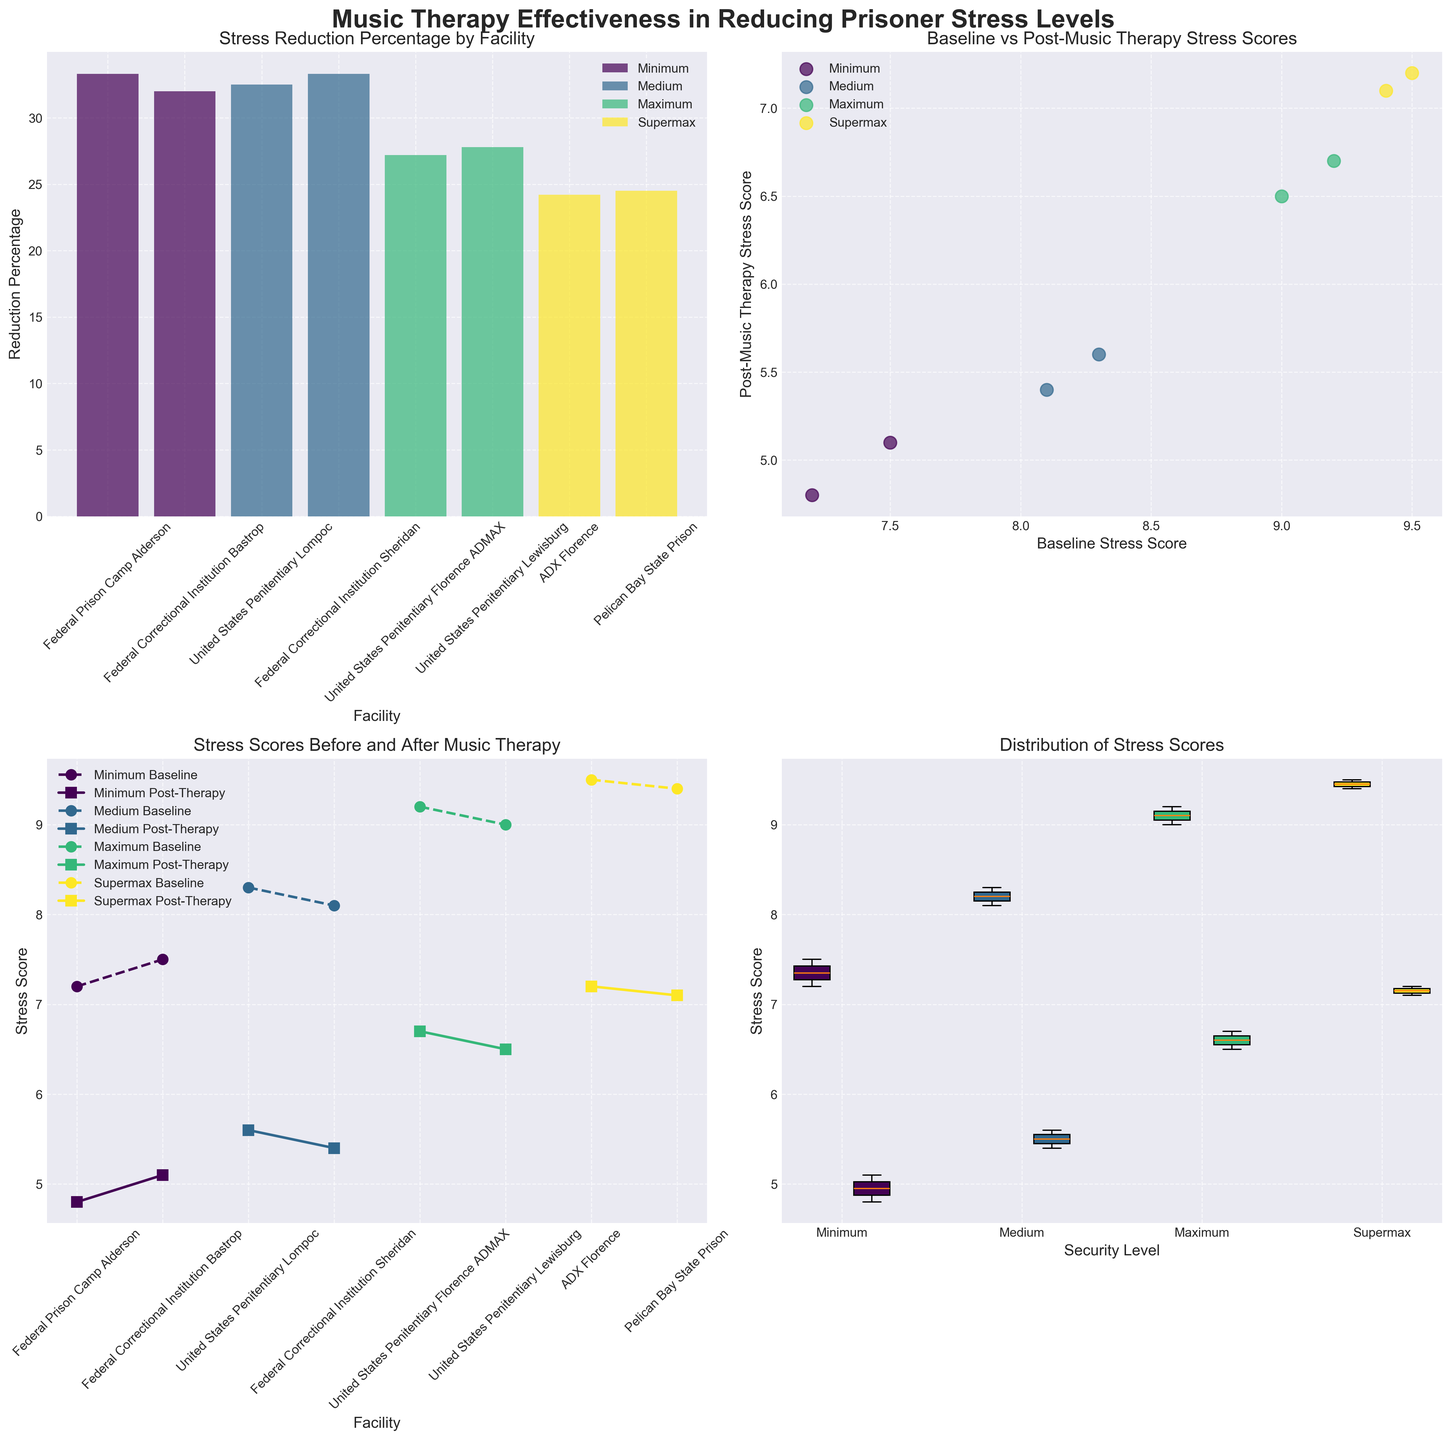Which facility within the Minimum Security Level shows the greatest reduction percentage? Look at the bar plot and identify the higher bar among the Minimum Security Level facilities. Federal Prison Camp Alderson shows a reduction percentage of 33.3, which is higher than 32.0 of the other facility.
Answer: Federal Prison Camp Alderson What's the difference between the Baseline and Post-Music Therapy Stress Scores for United States Penitentiary Florence ADMAX? Refer to the line plot and identify the values for Baseline and Post-Music Therapy Stress Scores for United States Penitentiary Florence ADMAX. The difference is calculated as 9.2 - 6.7.
Answer: 2.5 Which Security Level has the highest average Post-Music Therapy Stress Score? Look at the scatter plot for Post-Music Therapy Stress Scores for each Security Level. Calculate the average for each and compare. The Supermax level has the highest average with scores 7.2 and 7.1.
Answer: Supermax What is the range of Baseline Stress Scores in Medium Security Level facilities? Consult the boxplot for stress scores, paying attention to the range of Baseline Stress Scores in Medium Security Level. The scores range from 8.1 to 8.3.
Answer: 0.2 Compare the stress reduction percentage between Maximum and Supermax Security Levels. Which one is higher? Using the bar plot, identify the bars for Maximum and Supermax Security Levels. Compare the reduction percentages: Maximum shows percentages of 27.2 and 27.8, while Supermax shows 24.2 and 24.5.
Answer: Maximum Identify the facility with the highest Post-Music Therapy Stress Score. In the scatter plot, find the highest point on the Post-Music Therapy Stress Score axis. This corresponds to ADX Florence with a score of 7.2.
Answer: ADX Florence How does the baseline stress score at Federal Correctional Institution Sheridan compare to other facilities in Medium Security Level? Refer to the line plot for Medium Security Level. Compare the Baseline Stress Score of Federal Correctional Institution Sheridan (8.1) to United States Penitentiary Lompoc (8.3). Sheridan has a lower score.
Answer: Lower What is the total reduction percentage for Federal Correctional Institution Bastrop? Observe the reduction percentage in the bar plot for Federal Correctional Institution Bastrop. The reduction percentage is 32.0.
Answer: 32.0 How do the stress score reductions at Medium Security Level facilities compare to those at Minimum Security Level facilities? Assess the box plots for both security levels in terms of stress score reductions. Both levels show similar reductions, around 32-33%.
Answer: Similar 